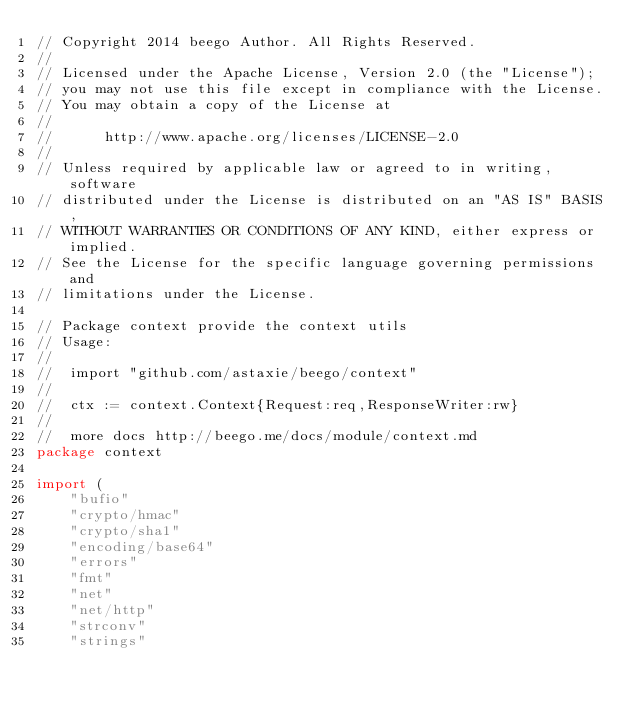Convert code to text. <code><loc_0><loc_0><loc_500><loc_500><_Go_>// Copyright 2014 beego Author. All Rights Reserved.
//
// Licensed under the Apache License, Version 2.0 (the "License");
// you may not use this file except in compliance with the License.
// You may obtain a copy of the License at
//
//      http://www.apache.org/licenses/LICENSE-2.0
//
// Unless required by applicable law or agreed to in writing, software
// distributed under the License is distributed on an "AS IS" BASIS,
// WITHOUT WARRANTIES OR CONDITIONS OF ANY KIND, either express or implied.
// See the License for the specific language governing permissions and
// limitations under the License.

// Package context provide the context utils
// Usage:
//
//	import "github.com/astaxie/beego/context"
//
//	ctx := context.Context{Request:req,ResponseWriter:rw}
//
//  more docs http://beego.me/docs/module/context.md
package context

import (
	"bufio"
	"crypto/hmac"
	"crypto/sha1"
	"encoding/base64"
	"errors"
	"fmt"
	"net"
	"net/http"
	"strconv"
	"strings"</code> 